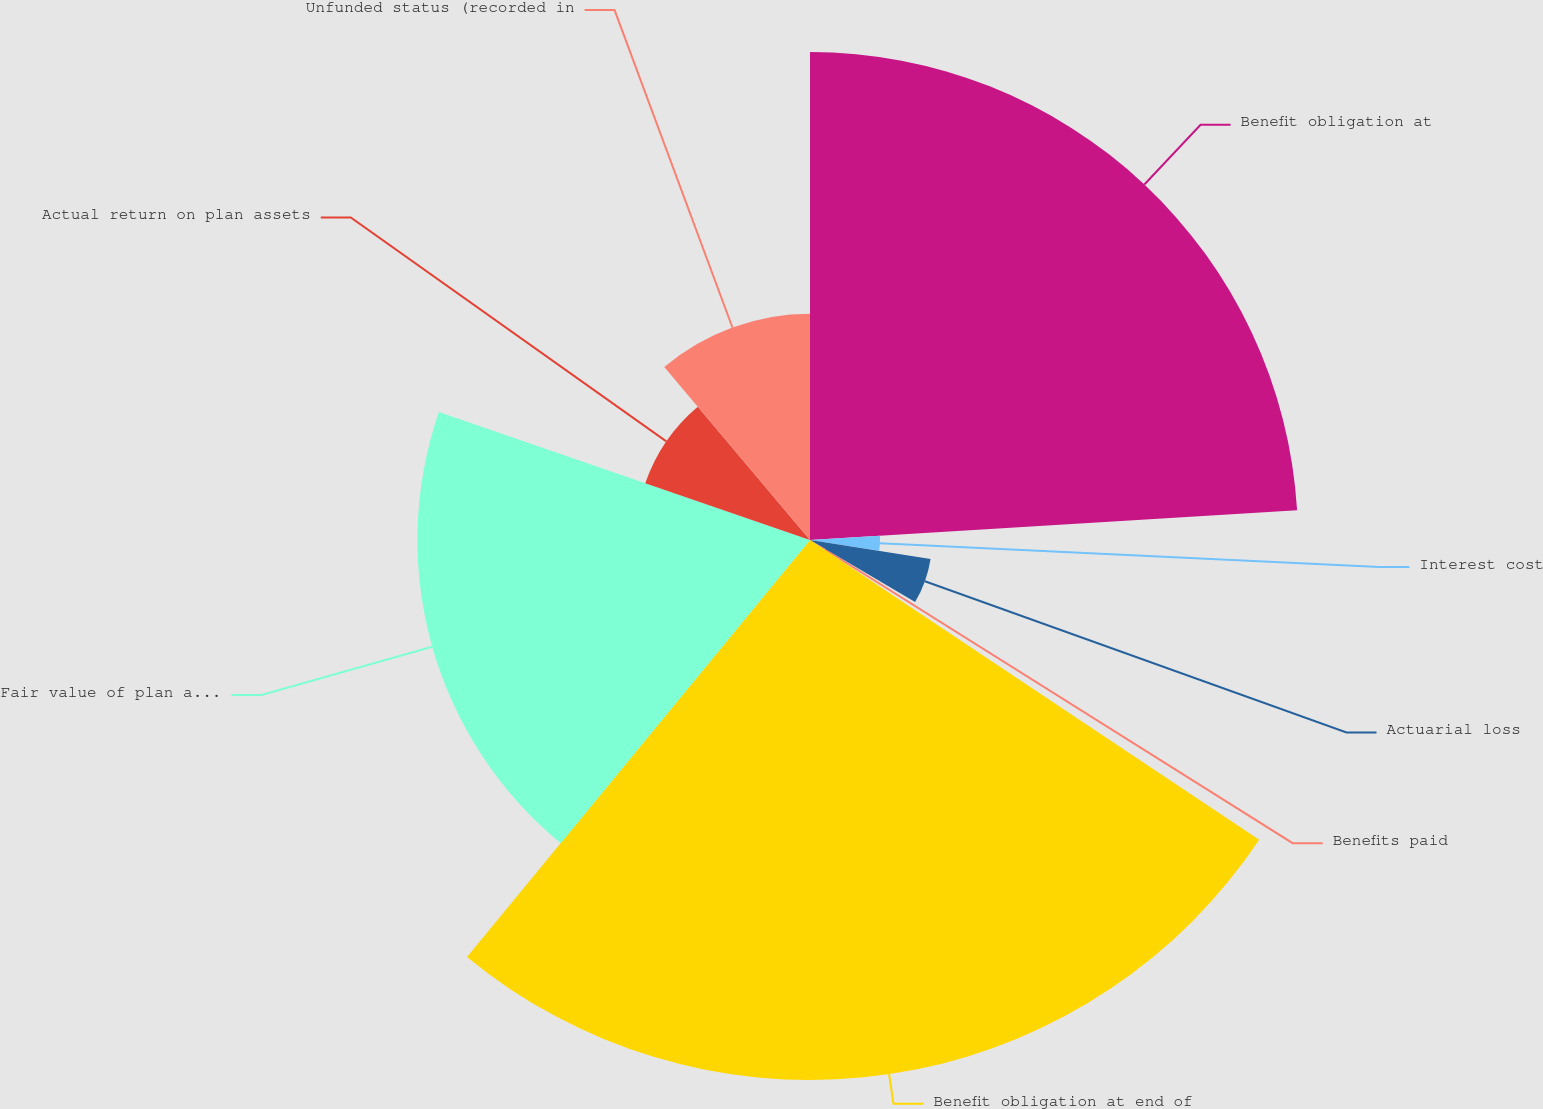Convert chart. <chart><loc_0><loc_0><loc_500><loc_500><pie_chart><fcel>Benefit obligation at<fcel>Interest cost<fcel>Actuarial loss<fcel>Benefits paid<fcel>Benefit obligation at end of<fcel>Fair value of plan assets at<fcel>Actual return on plan assets<fcel>Unfunded status (recorded in<nl><fcel>24.03%<fcel>3.45%<fcel>6.01%<fcel>0.88%<fcel>26.59%<fcel>19.33%<fcel>8.58%<fcel>11.14%<nl></chart> 